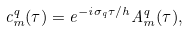Convert formula to latex. <formula><loc_0><loc_0><loc_500><loc_500>c ^ { q } _ { m } ( \tau ) = e ^ { - i \sigma _ { q } \tau / h } A ^ { q } _ { m } ( \tau ) ,</formula> 